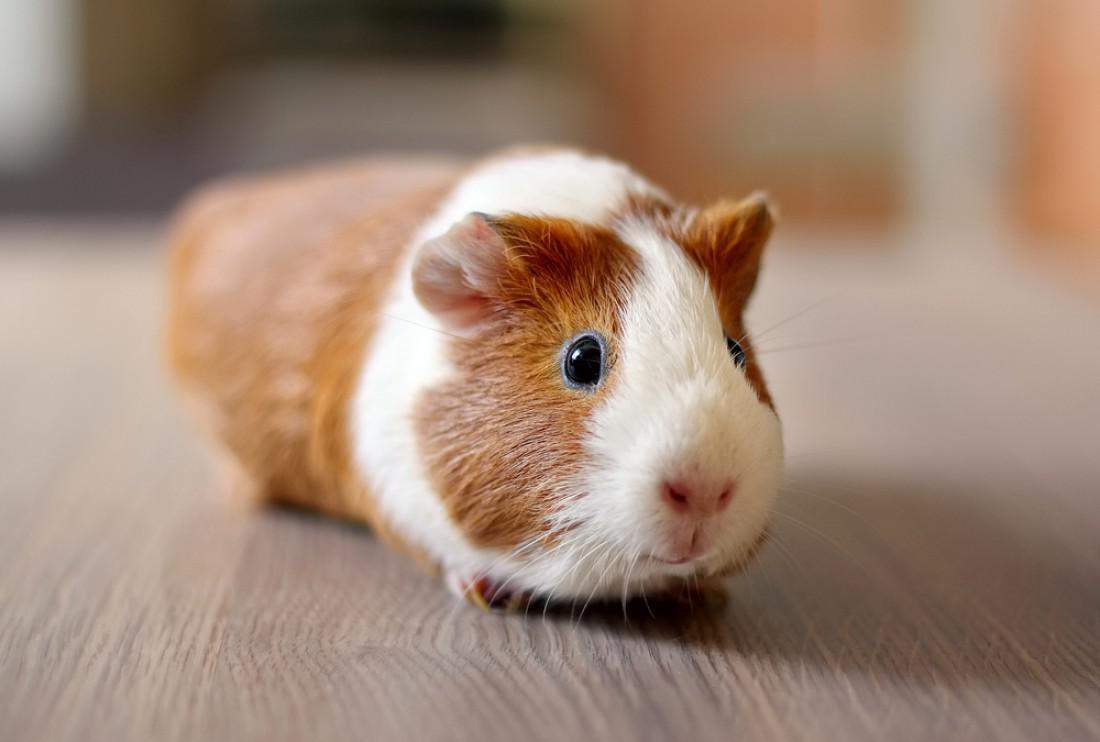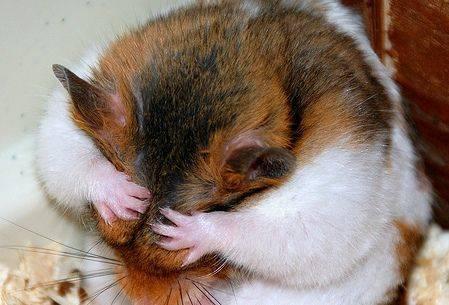The first image is the image on the left, the second image is the image on the right. Considering the images on both sides, is "One of the images shows a gerbil whose eyes are not visible." valid? Answer yes or no. Yes. The first image is the image on the left, the second image is the image on the right. For the images shown, is this caption "There is at least one animal whose eyes you cannot see at all." true? Answer yes or no. Yes. 